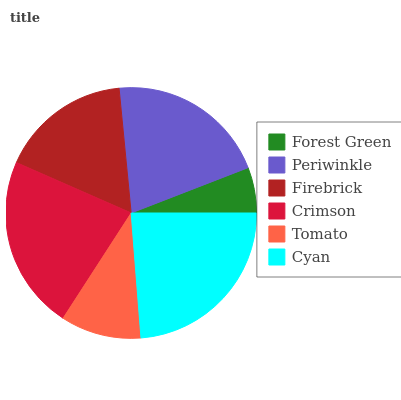Is Forest Green the minimum?
Answer yes or no. Yes. Is Cyan the maximum?
Answer yes or no. Yes. Is Periwinkle the minimum?
Answer yes or no. No. Is Periwinkle the maximum?
Answer yes or no. No. Is Periwinkle greater than Forest Green?
Answer yes or no. Yes. Is Forest Green less than Periwinkle?
Answer yes or no. Yes. Is Forest Green greater than Periwinkle?
Answer yes or no. No. Is Periwinkle less than Forest Green?
Answer yes or no. No. Is Periwinkle the high median?
Answer yes or no. Yes. Is Firebrick the low median?
Answer yes or no. Yes. Is Tomato the high median?
Answer yes or no. No. Is Forest Green the low median?
Answer yes or no. No. 